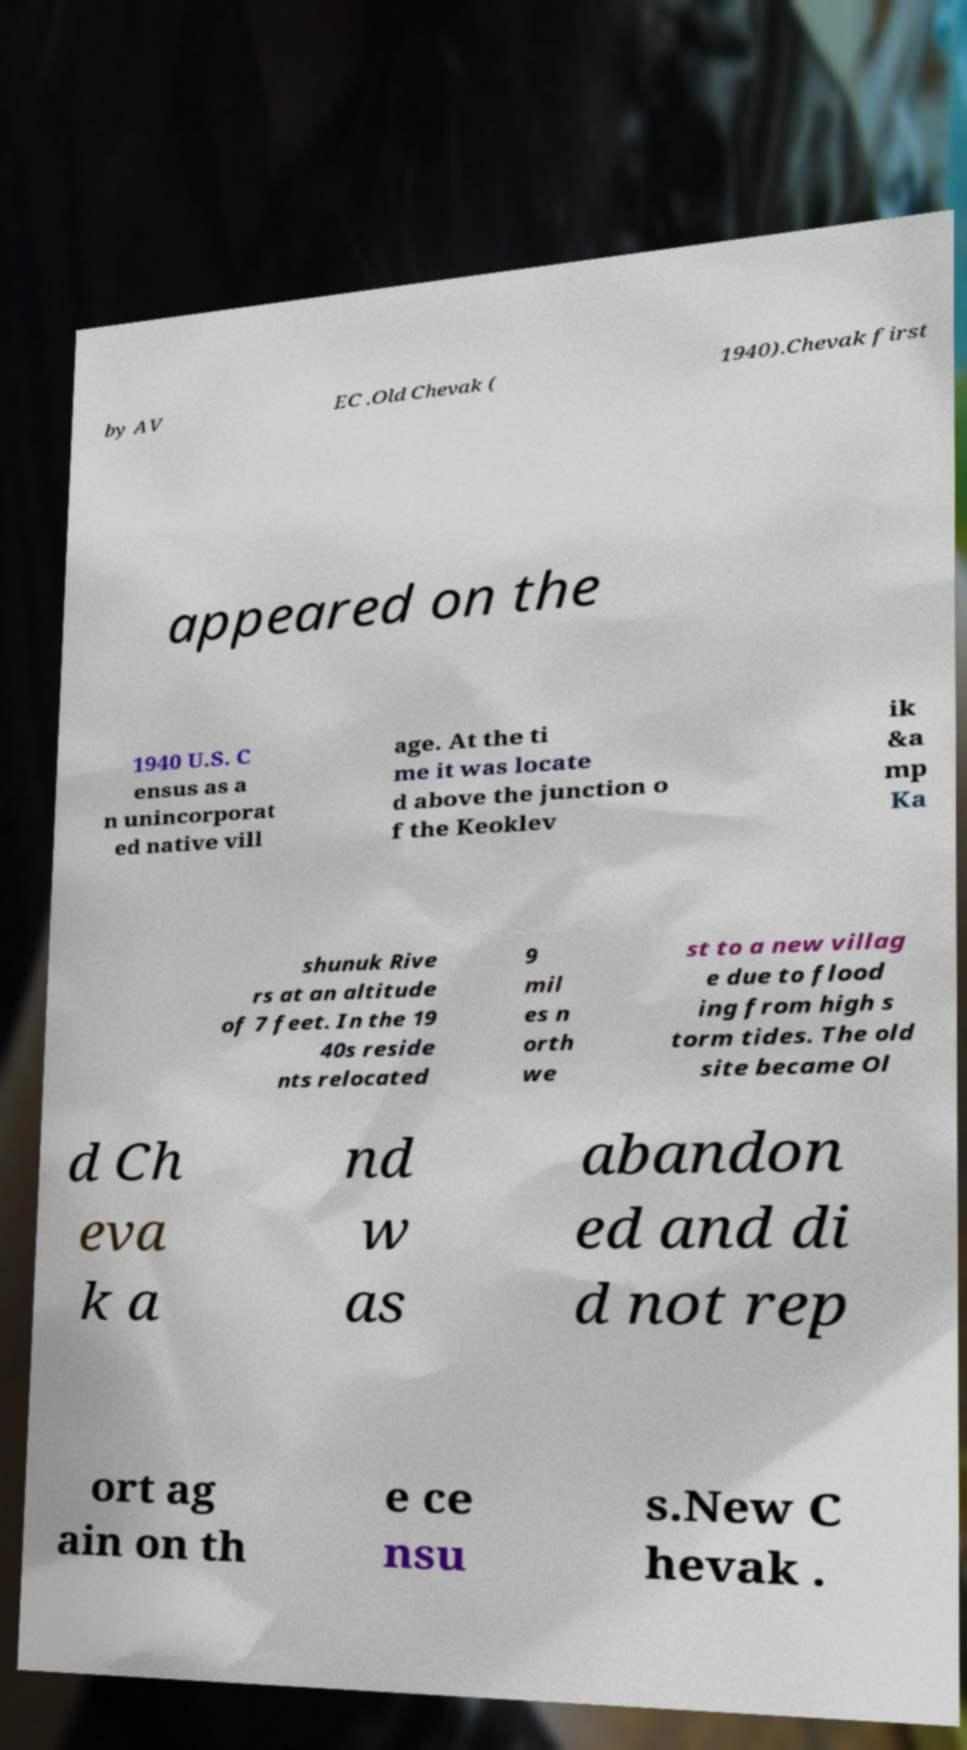Can you read and provide the text displayed in the image?This photo seems to have some interesting text. Can you extract and type it out for me? by AV EC .Old Chevak ( 1940).Chevak first appeared on the 1940 U.S. C ensus as a n unincorporat ed native vill age. At the ti me it was locate d above the junction o f the Keoklev ik &a mp Ka shunuk Rive rs at an altitude of 7 feet. In the 19 40s reside nts relocated 9 mil es n orth we st to a new villag e due to flood ing from high s torm tides. The old site became Ol d Ch eva k a nd w as abandon ed and di d not rep ort ag ain on th e ce nsu s.New C hevak . 